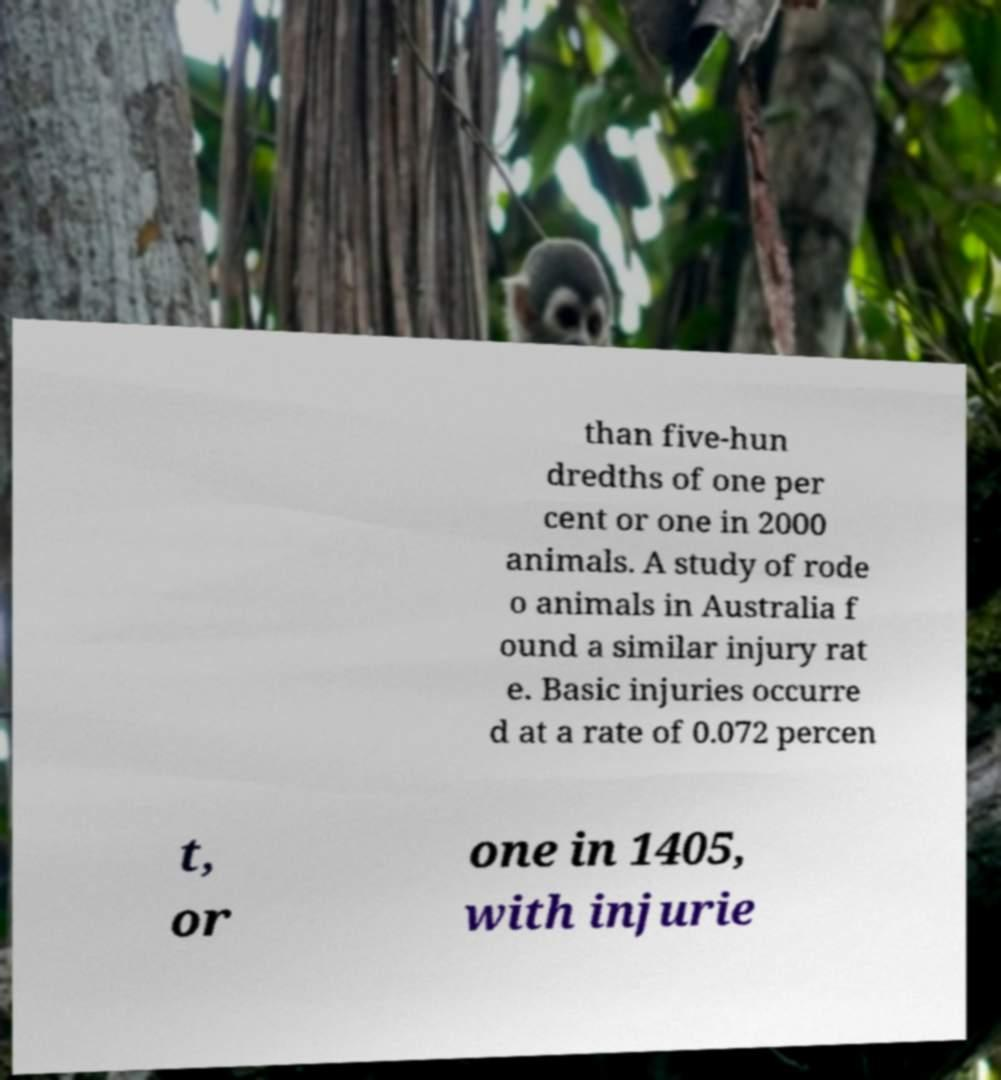Could you extract and type out the text from this image? than five-hun dredths of one per cent or one in 2000 animals. A study of rode o animals in Australia f ound a similar injury rat e. Basic injuries occurre d at a rate of 0.072 percen t, or one in 1405, with injurie 